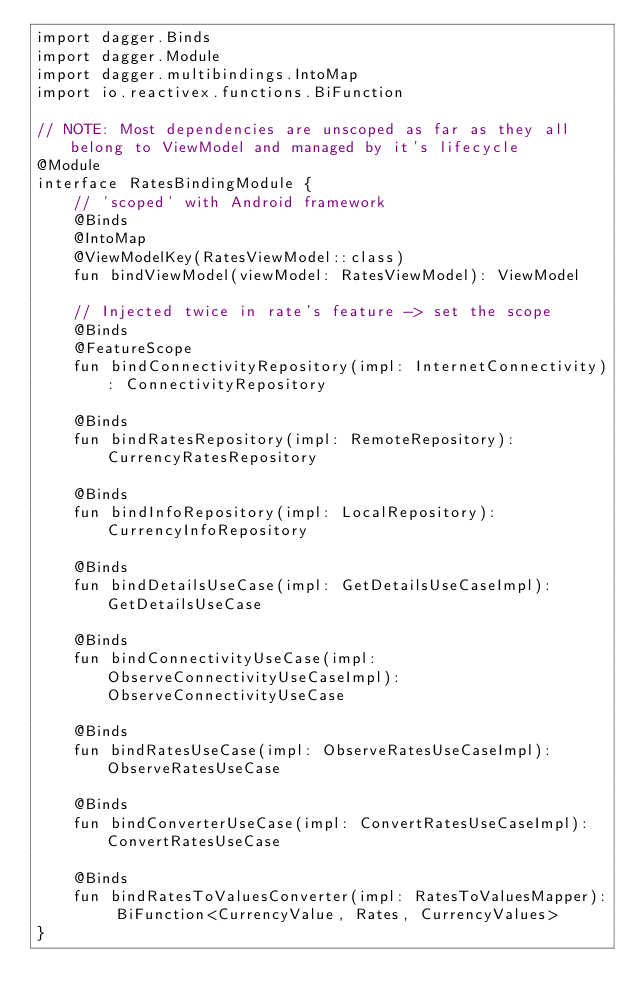<code> <loc_0><loc_0><loc_500><loc_500><_Kotlin_>import dagger.Binds
import dagger.Module
import dagger.multibindings.IntoMap
import io.reactivex.functions.BiFunction

// NOTE: Most dependencies are unscoped as far as they all belong to ViewModel and managed by it's lifecycle
@Module
interface RatesBindingModule {
    // 'scoped' with Android framework
    @Binds
    @IntoMap
    @ViewModelKey(RatesViewModel::class)
    fun bindViewModel(viewModel: RatesViewModel): ViewModel

    // Injected twice in rate's feature -> set the scope
    @Binds
    @FeatureScope
    fun bindConnectivityRepository(impl: InternetConnectivity): ConnectivityRepository

    @Binds
    fun bindRatesRepository(impl: RemoteRepository): CurrencyRatesRepository

    @Binds
    fun bindInfoRepository(impl: LocalRepository): CurrencyInfoRepository

    @Binds
    fun bindDetailsUseCase(impl: GetDetailsUseCaseImpl): GetDetailsUseCase

    @Binds
    fun bindConnectivityUseCase(impl: ObserveConnectivityUseCaseImpl): ObserveConnectivityUseCase

    @Binds
    fun bindRatesUseCase(impl: ObserveRatesUseCaseImpl): ObserveRatesUseCase

    @Binds
    fun bindConverterUseCase(impl: ConvertRatesUseCaseImpl): ConvertRatesUseCase

    @Binds
    fun bindRatesToValuesConverter(impl: RatesToValuesMapper): BiFunction<CurrencyValue, Rates, CurrencyValues>
}

</code> 